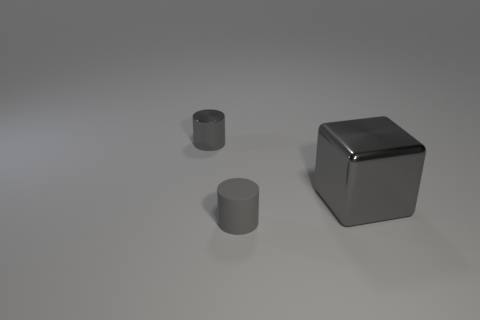Add 2 large brown metallic balls. How many objects exist? 5 Subtract all blue blocks. Subtract all red balls. How many blocks are left? 1 Subtract all blocks. How many objects are left? 2 Subtract 0 red balls. How many objects are left? 3 Subtract all gray shiny things. Subtract all blue metallic objects. How many objects are left? 1 Add 1 gray blocks. How many gray blocks are left? 2 Add 3 small gray matte things. How many small gray matte things exist? 4 